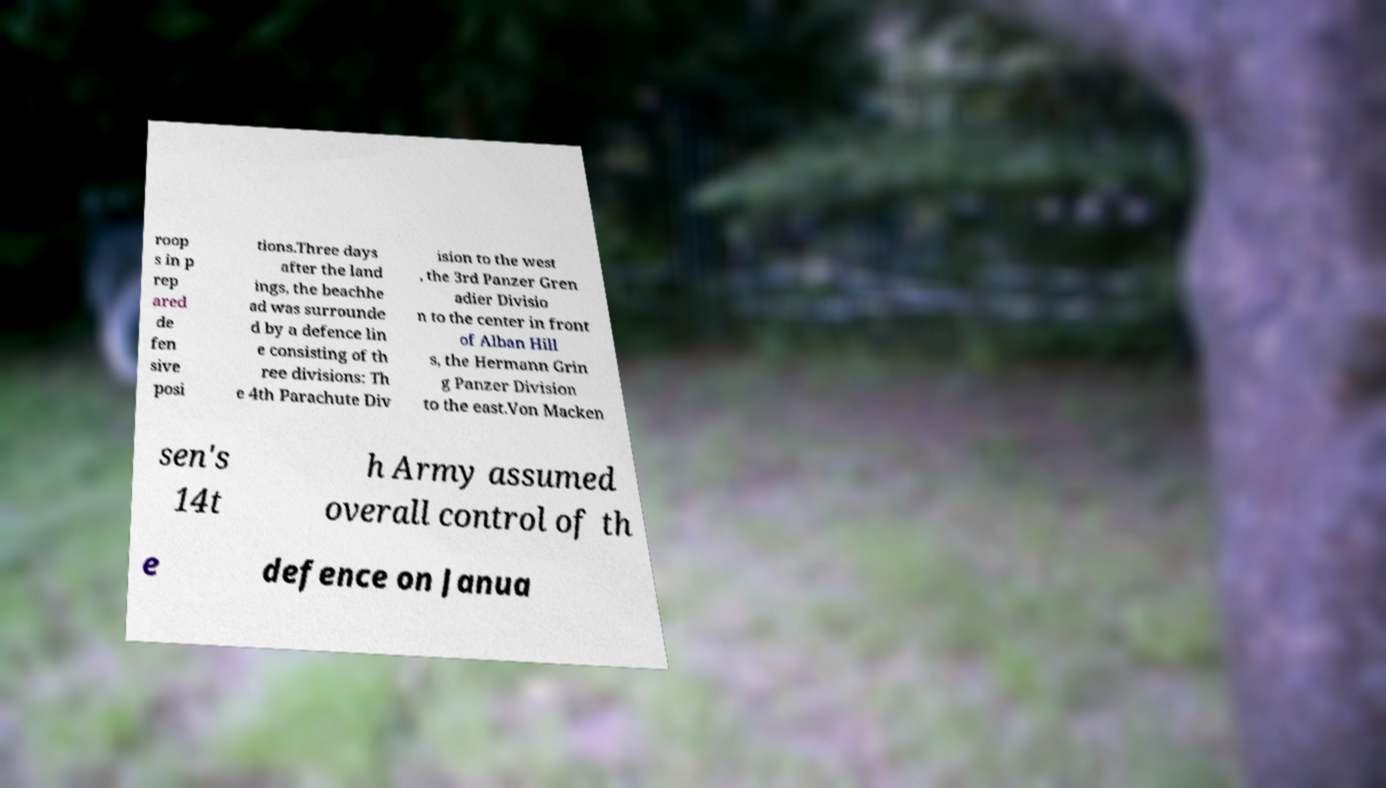Could you extract and type out the text from this image? roop s in p rep ared de fen sive posi tions.Three days after the land ings, the beachhe ad was surrounde d by a defence lin e consisting of th ree divisions: Th e 4th Parachute Div ision to the west , the 3rd Panzer Gren adier Divisio n to the center in front of Alban Hill s, the Hermann Grin g Panzer Division to the east.Von Macken sen's 14t h Army assumed overall control of th e defence on Janua 